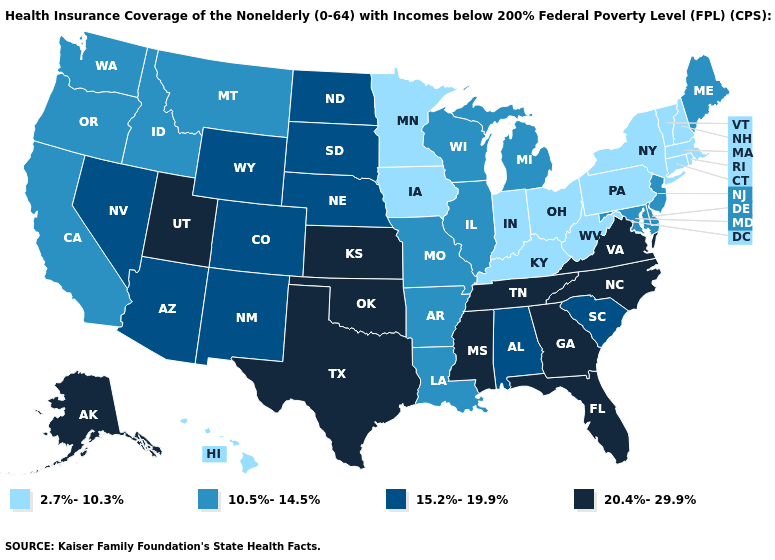Does West Virginia have the highest value in the South?
Short answer required. No. Does Maine have a higher value than Vermont?
Answer briefly. Yes. Is the legend a continuous bar?
Write a very short answer. No. What is the lowest value in the South?
Concise answer only. 2.7%-10.3%. What is the value of Wisconsin?
Keep it brief. 10.5%-14.5%. Name the states that have a value in the range 2.7%-10.3%?
Short answer required. Connecticut, Hawaii, Indiana, Iowa, Kentucky, Massachusetts, Minnesota, New Hampshire, New York, Ohio, Pennsylvania, Rhode Island, Vermont, West Virginia. Name the states that have a value in the range 20.4%-29.9%?
Answer briefly. Alaska, Florida, Georgia, Kansas, Mississippi, North Carolina, Oklahoma, Tennessee, Texas, Utah, Virginia. What is the highest value in states that border Vermont?
Give a very brief answer. 2.7%-10.3%. Is the legend a continuous bar?
Be succinct. No. What is the value of Oregon?
Answer briefly. 10.5%-14.5%. Which states have the highest value in the USA?
Quick response, please. Alaska, Florida, Georgia, Kansas, Mississippi, North Carolina, Oklahoma, Tennessee, Texas, Utah, Virginia. Name the states that have a value in the range 2.7%-10.3%?
Write a very short answer. Connecticut, Hawaii, Indiana, Iowa, Kentucky, Massachusetts, Minnesota, New Hampshire, New York, Ohio, Pennsylvania, Rhode Island, Vermont, West Virginia. What is the value of North Carolina?
Write a very short answer. 20.4%-29.9%. Name the states that have a value in the range 20.4%-29.9%?
Concise answer only. Alaska, Florida, Georgia, Kansas, Mississippi, North Carolina, Oklahoma, Tennessee, Texas, Utah, Virginia. What is the highest value in the USA?
Write a very short answer. 20.4%-29.9%. 